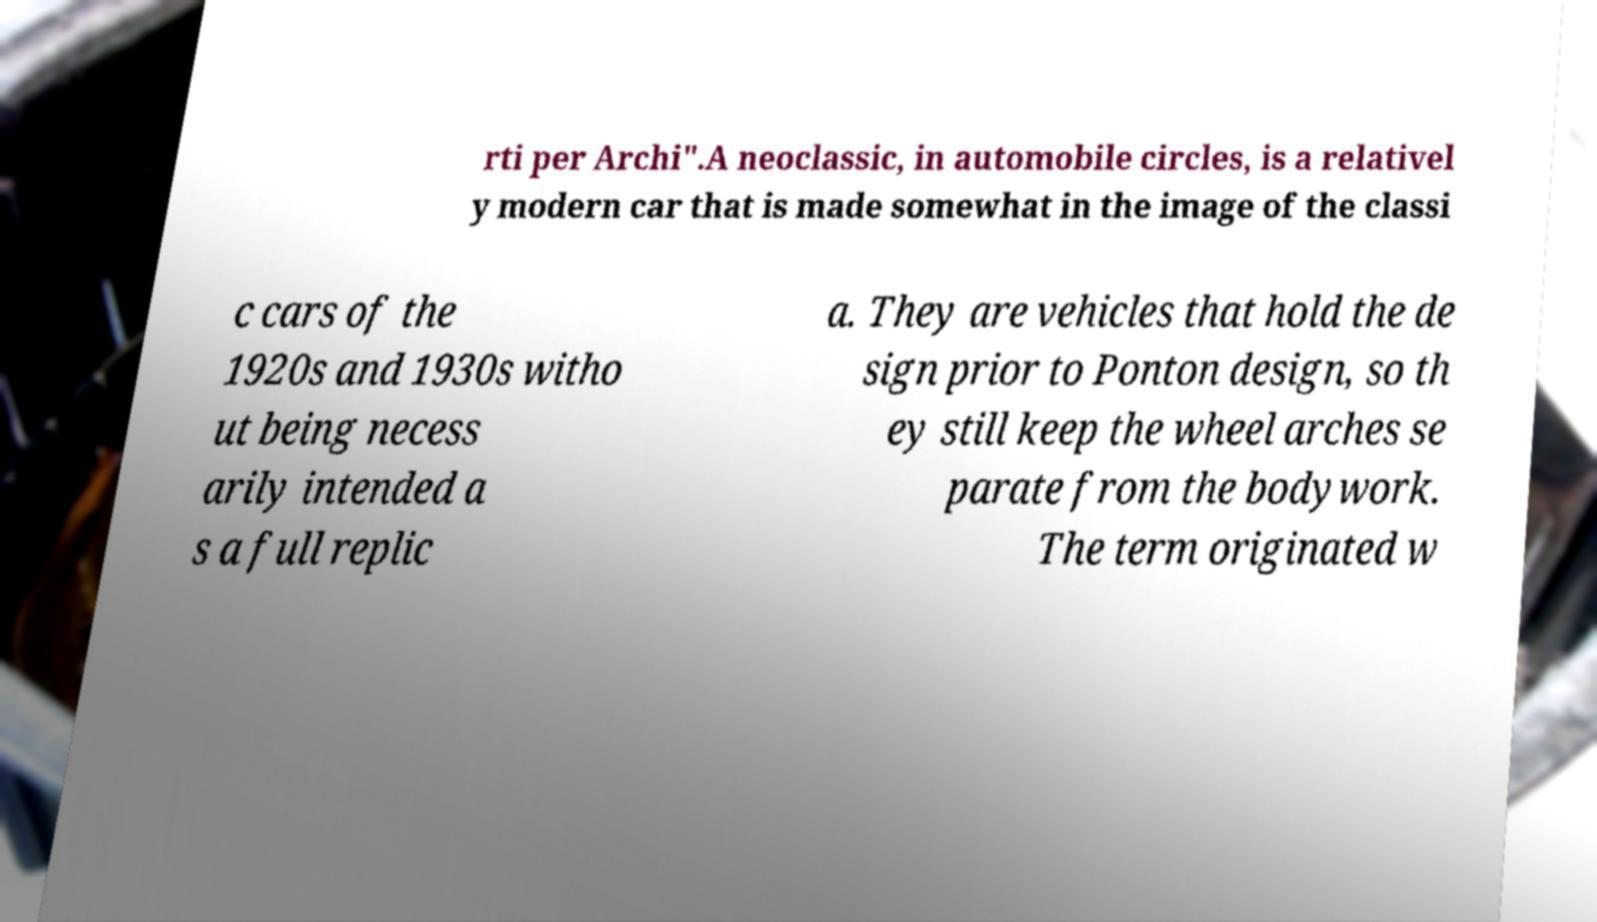There's text embedded in this image that I need extracted. Can you transcribe it verbatim? rti per Archi".A neoclassic, in automobile circles, is a relativel y modern car that is made somewhat in the image of the classi c cars of the 1920s and 1930s witho ut being necess arily intended a s a full replic a. They are vehicles that hold the de sign prior to Ponton design, so th ey still keep the wheel arches se parate from the bodywork. The term originated w 